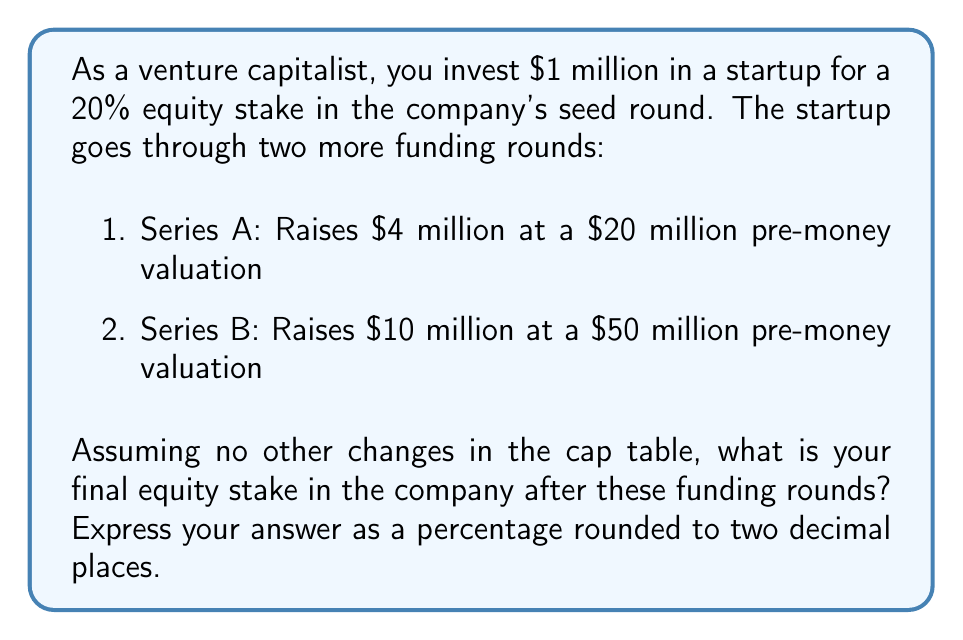What is the answer to this math problem? Let's approach this step-by-step:

1. Initial investment (Seed round):
   - You invest $1 million for 20% equity
   - Implied post-money valuation: $1 million / 0.20 = $5 million

2. Series A:
   - Pre-money valuation: $20 million
   - New investment: $4 million
   - Post-money valuation: $20 million + $4 million = $24 million
   - Dilution factor: $20 million / $24 million = 0.8333

   Your new equity stake: 20% * 0.8333 = 16.67%

3. Series B:
   - Pre-money valuation: $50 million
   - New investment: $10 million
   - Post-money valuation: $50 million + $10 million = $60 million
   - Dilution factor: $50 million / $60 million = 0.8333

   Your new equity stake: 16.67% * 0.8333 = 13.89%

We can also calculate this using the following formula:

$$ \text{Final Equity} = \text{Initial Equity} \times \prod_{i=1}^{n} \frac{\text{Pre-money Valuation}_i}{\text{Post-money Valuation}_i} $$

Where $n$ is the number of funding rounds after the initial investment.

$$ \text{Final Equity} = 20\% \times \frac{20}{24} \times \frac{50}{60} = 20\% \times 0.8333 \times 0.8333 = 13.89\% $$
Answer: 13.89% 